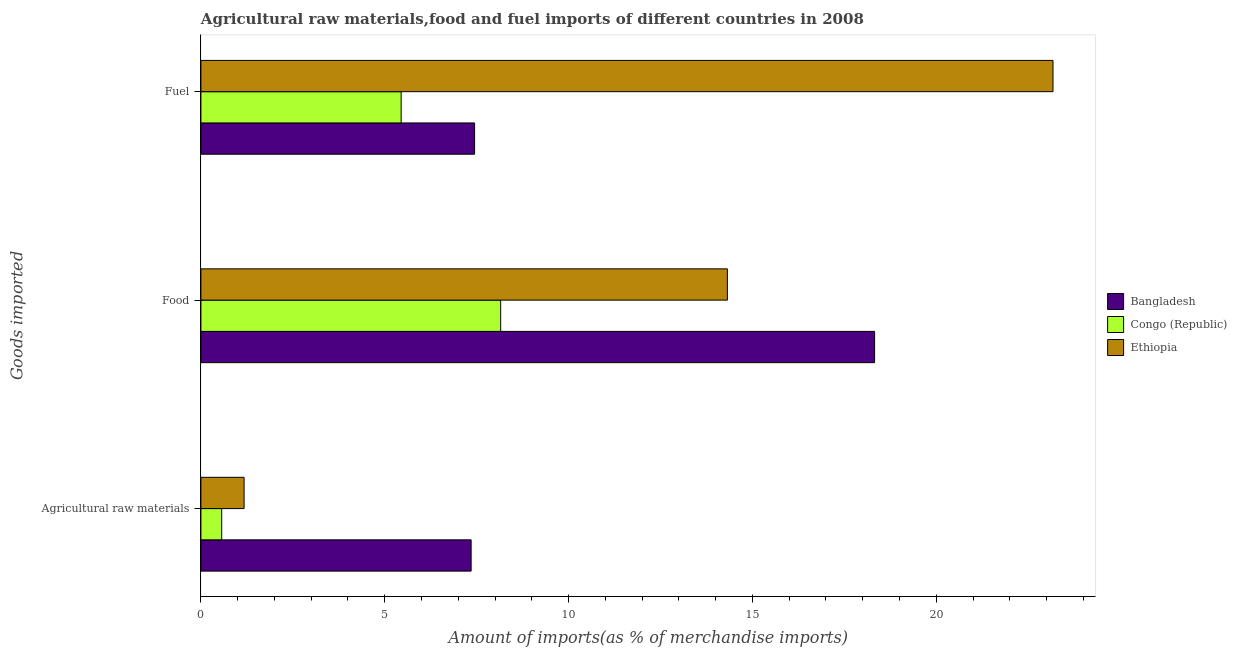Are the number of bars per tick equal to the number of legend labels?
Give a very brief answer. Yes. Are the number of bars on each tick of the Y-axis equal?
Give a very brief answer. Yes. How many bars are there on the 2nd tick from the top?
Your answer should be very brief. 3. What is the label of the 1st group of bars from the top?
Provide a short and direct response. Fuel. What is the percentage of fuel imports in Congo (Republic)?
Give a very brief answer. 5.45. Across all countries, what is the maximum percentage of fuel imports?
Give a very brief answer. 23.17. Across all countries, what is the minimum percentage of raw materials imports?
Your answer should be compact. 0.56. In which country was the percentage of food imports maximum?
Offer a terse response. Bangladesh. In which country was the percentage of raw materials imports minimum?
Your answer should be compact. Congo (Republic). What is the total percentage of raw materials imports in the graph?
Provide a short and direct response. 9.09. What is the difference between the percentage of raw materials imports in Ethiopia and that in Congo (Republic)?
Provide a succinct answer. 0.61. What is the difference between the percentage of fuel imports in Ethiopia and the percentage of raw materials imports in Bangladesh?
Your answer should be very brief. 15.82. What is the average percentage of fuel imports per country?
Give a very brief answer. 12.02. What is the difference between the percentage of raw materials imports and percentage of fuel imports in Ethiopia?
Ensure brevity in your answer.  -22. What is the ratio of the percentage of raw materials imports in Ethiopia to that in Congo (Republic)?
Provide a succinct answer. 2.08. Is the difference between the percentage of fuel imports in Bangladesh and Congo (Republic) greater than the difference between the percentage of food imports in Bangladesh and Congo (Republic)?
Your answer should be very brief. No. What is the difference between the highest and the second highest percentage of fuel imports?
Offer a very short reply. 15.73. What is the difference between the highest and the lowest percentage of fuel imports?
Make the answer very short. 17.73. Is the sum of the percentage of raw materials imports in Congo (Republic) and Ethiopia greater than the maximum percentage of fuel imports across all countries?
Offer a terse response. No. Is it the case that in every country, the sum of the percentage of raw materials imports and percentage of food imports is greater than the percentage of fuel imports?
Your answer should be compact. No. How many bars are there?
Your response must be concise. 9. How many countries are there in the graph?
Your answer should be compact. 3. What is the difference between two consecutive major ticks on the X-axis?
Provide a short and direct response. 5. Where does the legend appear in the graph?
Provide a short and direct response. Center right. How many legend labels are there?
Offer a very short reply. 3. How are the legend labels stacked?
Make the answer very short. Vertical. What is the title of the graph?
Offer a very short reply. Agricultural raw materials,food and fuel imports of different countries in 2008. Does "Togo" appear as one of the legend labels in the graph?
Offer a terse response. No. What is the label or title of the X-axis?
Your response must be concise. Amount of imports(as % of merchandise imports). What is the label or title of the Y-axis?
Make the answer very short. Goods imported. What is the Amount of imports(as % of merchandise imports) of Bangladesh in Agricultural raw materials?
Keep it short and to the point. 7.35. What is the Amount of imports(as % of merchandise imports) in Congo (Republic) in Agricultural raw materials?
Offer a terse response. 0.56. What is the Amount of imports(as % of merchandise imports) of Ethiopia in Agricultural raw materials?
Offer a very short reply. 1.17. What is the Amount of imports(as % of merchandise imports) of Bangladesh in Food?
Offer a terse response. 18.32. What is the Amount of imports(as % of merchandise imports) of Congo (Republic) in Food?
Your answer should be very brief. 8.15. What is the Amount of imports(as % of merchandise imports) of Ethiopia in Food?
Make the answer very short. 14.32. What is the Amount of imports(as % of merchandise imports) of Bangladesh in Fuel?
Your answer should be very brief. 7.44. What is the Amount of imports(as % of merchandise imports) in Congo (Republic) in Fuel?
Keep it short and to the point. 5.45. What is the Amount of imports(as % of merchandise imports) in Ethiopia in Fuel?
Your answer should be very brief. 23.17. Across all Goods imported, what is the maximum Amount of imports(as % of merchandise imports) of Bangladesh?
Your response must be concise. 18.32. Across all Goods imported, what is the maximum Amount of imports(as % of merchandise imports) in Congo (Republic)?
Make the answer very short. 8.15. Across all Goods imported, what is the maximum Amount of imports(as % of merchandise imports) of Ethiopia?
Your answer should be very brief. 23.17. Across all Goods imported, what is the minimum Amount of imports(as % of merchandise imports) of Bangladesh?
Provide a short and direct response. 7.35. Across all Goods imported, what is the minimum Amount of imports(as % of merchandise imports) of Congo (Republic)?
Your response must be concise. 0.56. Across all Goods imported, what is the minimum Amount of imports(as % of merchandise imports) of Ethiopia?
Your answer should be compact. 1.17. What is the total Amount of imports(as % of merchandise imports) in Bangladesh in the graph?
Offer a terse response. 33.12. What is the total Amount of imports(as % of merchandise imports) in Congo (Republic) in the graph?
Provide a short and direct response. 14.16. What is the total Amount of imports(as % of merchandise imports) in Ethiopia in the graph?
Provide a short and direct response. 38.67. What is the difference between the Amount of imports(as % of merchandise imports) in Bangladesh in Agricultural raw materials and that in Food?
Your answer should be very brief. -10.97. What is the difference between the Amount of imports(as % of merchandise imports) in Congo (Republic) in Agricultural raw materials and that in Food?
Your answer should be very brief. -7.59. What is the difference between the Amount of imports(as % of merchandise imports) of Ethiopia in Agricultural raw materials and that in Food?
Give a very brief answer. -13.14. What is the difference between the Amount of imports(as % of merchandise imports) in Bangladesh in Agricultural raw materials and that in Fuel?
Your answer should be compact. -0.09. What is the difference between the Amount of imports(as % of merchandise imports) of Congo (Republic) in Agricultural raw materials and that in Fuel?
Keep it short and to the point. -4.88. What is the difference between the Amount of imports(as % of merchandise imports) of Ethiopia in Agricultural raw materials and that in Fuel?
Make the answer very short. -22. What is the difference between the Amount of imports(as % of merchandise imports) of Bangladesh in Food and that in Fuel?
Provide a short and direct response. 10.88. What is the difference between the Amount of imports(as % of merchandise imports) of Congo (Republic) in Food and that in Fuel?
Give a very brief answer. 2.71. What is the difference between the Amount of imports(as % of merchandise imports) of Ethiopia in Food and that in Fuel?
Your answer should be very brief. -8.86. What is the difference between the Amount of imports(as % of merchandise imports) of Bangladesh in Agricultural raw materials and the Amount of imports(as % of merchandise imports) of Congo (Republic) in Food?
Your response must be concise. -0.8. What is the difference between the Amount of imports(as % of merchandise imports) of Bangladesh in Agricultural raw materials and the Amount of imports(as % of merchandise imports) of Ethiopia in Food?
Give a very brief answer. -6.97. What is the difference between the Amount of imports(as % of merchandise imports) in Congo (Republic) in Agricultural raw materials and the Amount of imports(as % of merchandise imports) in Ethiopia in Food?
Your response must be concise. -13.75. What is the difference between the Amount of imports(as % of merchandise imports) of Bangladesh in Agricultural raw materials and the Amount of imports(as % of merchandise imports) of Congo (Republic) in Fuel?
Ensure brevity in your answer.  1.9. What is the difference between the Amount of imports(as % of merchandise imports) of Bangladesh in Agricultural raw materials and the Amount of imports(as % of merchandise imports) of Ethiopia in Fuel?
Offer a terse response. -15.82. What is the difference between the Amount of imports(as % of merchandise imports) in Congo (Republic) in Agricultural raw materials and the Amount of imports(as % of merchandise imports) in Ethiopia in Fuel?
Your answer should be very brief. -22.61. What is the difference between the Amount of imports(as % of merchandise imports) in Bangladesh in Food and the Amount of imports(as % of merchandise imports) in Congo (Republic) in Fuel?
Offer a terse response. 12.88. What is the difference between the Amount of imports(as % of merchandise imports) in Bangladesh in Food and the Amount of imports(as % of merchandise imports) in Ethiopia in Fuel?
Your answer should be very brief. -4.85. What is the difference between the Amount of imports(as % of merchandise imports) of Congo (Republic) in Food and the Amount of imports(as % of merchandise imports) of Ethiopia in Fuel?
Provide a short and direct response. -15.02. What is the average Amount of imports(as % of merchandise imports) in Bangladesh per Goods imported?
Ensure brevity in your answer.  11.04. What is the average Amount of imports(as % of merchandise imports) of Congo (Republic) per Goods imported?
Provide a short and direct response. 4.72. What is the average Amount of imports(as % of merchandise imports) in Ethiopia per Goods imported?
Provide a succinct answer. 12.89. What is the difference between the Amount of imports(as % of merchandise imports) in Bangladesh and Amount of imports(as % of merchandise imports) in Congo (Republic) in Agricultural raw materials?
Offer a very short reply. 6.78. What is the difference between the Amount of imports(as % of merchandise imports) of Bangladesh and Amount of imports(as % of merchandise imports) of Ethiopia in Agricultural raw materials?
Provide a succinct answer. 6.17. What is the difference between the Amount of imports(as % of merchandise imports) in Congo (Republic) and Amount of imports(as % of merchandise imports) in Ethiopia in Agricultural raw materials?
Offer a terse response. -0.61. What is the difference between the Amount of imports(as % of merchandise imports) in Bangladesh and Amount of imports(as % of merchandise imports) in Congo (Republic) in Food?
Give a very brief answer. 10.17. What is the difference between the Amount of imports(as % of merchandise imports) in Bangladesh and Amount of imports(as % of merchandise imports) in Ethiopia in Food?
Provide a succinct answer. 4. What is the difference between the Amount of imports(as % of merchandise imports) in Congo (Republic) and Amount of imports(as % of merchandise imports) in Ethiopia in Food?
Your response must be concise. -6.17. What is the difference between the Amount of imports(as % of merchandise imports) in Bangladesh and Amount of imports(as % of merchandise imports) in Congo (Republic) in Fuel?
Provide a succinct answer. 2. What is the difference between the Amount of imports(as % of merchandise imports) of Bangladesh and Amount of imports(as % of merchandise imports) of Ethiopia in Fuel?
Your response must be concise. -15.73. What is the difference between the Amount of imports(as % of merchandise imports) in Congo (Republic) and Amount of imports(as % of merchandise imports) in Ethiopia in Fuel?
Keep it short and to the point. -17.73. What is the ratio of the Amount of imports(as % of merchandise imports) of Bangladesh in Agricultural raw materials to that in Food?
Ensure brevity in your answer.  0.4. What is the ratio of the Amount of imports(as % of merchandise imports) in Congo (Republic) in Agricultural raw materials to that in Food?
Provide a succinct answer. 0.07. What is the ratio of the Amount of imports(as % of merchandise imports) of Ethiopia in Agricultural raw materials to that in Food?
Your answer should be compact. 0.08. What is the ratio of the Amount of imports(as % of merchandise imports) of Bangladesh in Agricultural raw materials to that in Fuel?
Ensure brevity in your answer.  0.99. What is the ratio of the Amount of imports(as % of merchandise imports) of Congo (Republic) in Agricultural raw materials to that in Fuel?
Offer a very short reply. 0.1. What is the ratio of the Amount of imports(as % of merchandise imports) of Ethiopia in Agricultural raw materials to that in Fuel?
Give a very brief answer. 0.05. What is the ratio of the Amount of imports(as % of merchandise imports) in Bangladesh in Food to that in Fuel?
Provide a short and direct response. 2.46. What is the ratio of the Amount of imports(as % of merchandise imports) of Congo (Republic) in Food to that in Fuel?
Your answer should be very brief. 1.5. What is the ratio of the Amount of imports(as % of merchandise imports) in Ethiopia in Food to that in Fuel?
Provide a succinct answer. 0.62. What is the difference between the highest and the second highest Amount of imports(as % of merchandise imports) in Bangladesh?
Your answer should be compact. 10.88. What is the difference between the highest and the second highest Amount of imports(as % of merchandise imports) in Congo (Republic)?
Keep it short and to the point. 2.71. What is the difference between the highest and the second highest Amount of imports(as % of merchandise imports) of Ethiopia?
Your answer should be compact. 8.86. What is the difference between the highest and the lowest Amount of imports(as % of merchandise imports) of Bangladesh?
Make the answer very short. 10.97. What is the difference between the highest and the lowest Amount of imports(as % of merchandise imports) of Congo (Republic)?
Your answer should be very brief. 7.59. What is the difference between the highest and the lowest Amount of imports(as % of merchandise imports) of Ethiopia?
Make the answer very short. 22. 